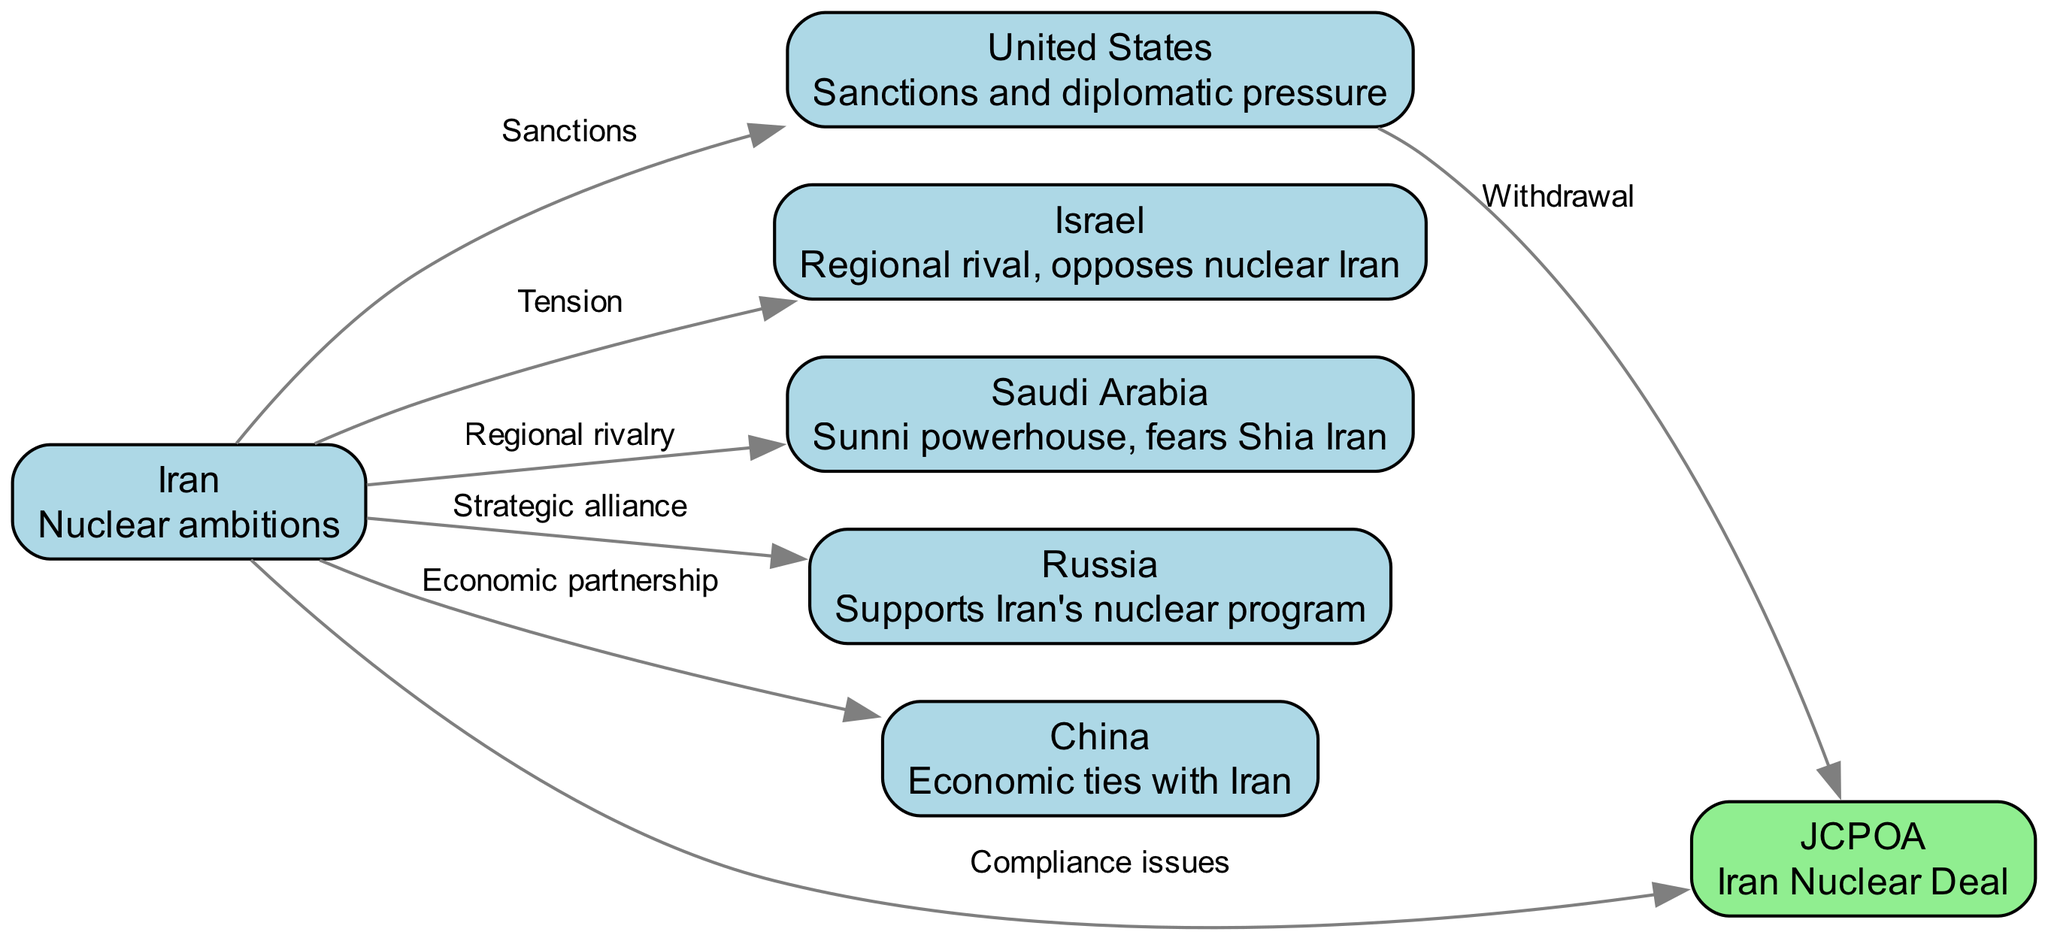What are the four countries represented in the diagram? The diagram includes nodes for Iran, USA, Israel, and Saudi Arabia, which are all labeled clearly as distinct countries within the geopolitical context.
Answer: Iran, USA, Israel, Saudi Arabia How many edges are there in the diagram? By counting the connections depicted between the nodes, we find there are a total of six edges representing various relationships among the countries and the JCPOA.
Answer: 6 What type of alliance does Iran have with Russia? The diagram specifies the relationship between Iran and Russia as a strategic alliance, which is indicated by the edge label connecting these two nodes.
Answer: Strategic alliance What action did the USA take regarding the JCPOA? The edge connecting the USA to the JCPOA is labeled "Withdrawal," which indicates that the USA has taken a definitive action affecting its relationship with the Iran Nuclear Deal.
Answer: Withdrawal Which country is described as a Sunni powerhouse fearing Shia Iran? In the diagram, Saudi Arabia is clearly described as a Sunni powerhouse that fears the Shia influence of Iran, thus identifying the country corresponding to this description.
Answer: Saudi Arabia How is Iran's relationship with China characterized? The edge between Iran and China is labeled as an "Economic partnership," which indicates the nature of their bilateral relationship in the context of the diagram.
Answer: Economic partnership What is the label of the edge between Iran and Israel? The relationship between Iran and Israel is characterized by tension, which is clearly indicated by the label of the edge connecting these two nodes in the diagram.
Answer: Tension Which agreement is referenced in the diagram involving compliance issues? The JCPOA, or Iran Nuclear Deal, is connected to Iran with an edge labeled "Compliance issues," denoting the agreement referred to in this context.
Answer: JCPOA Who supports Iran's nuclear program according to the diagram? The diagram indicates that Russia supports Iran's nuclear program, as evidenced by the edge connecting these two nodes with the label 'Strategic alliance.'
Answer: Russia 